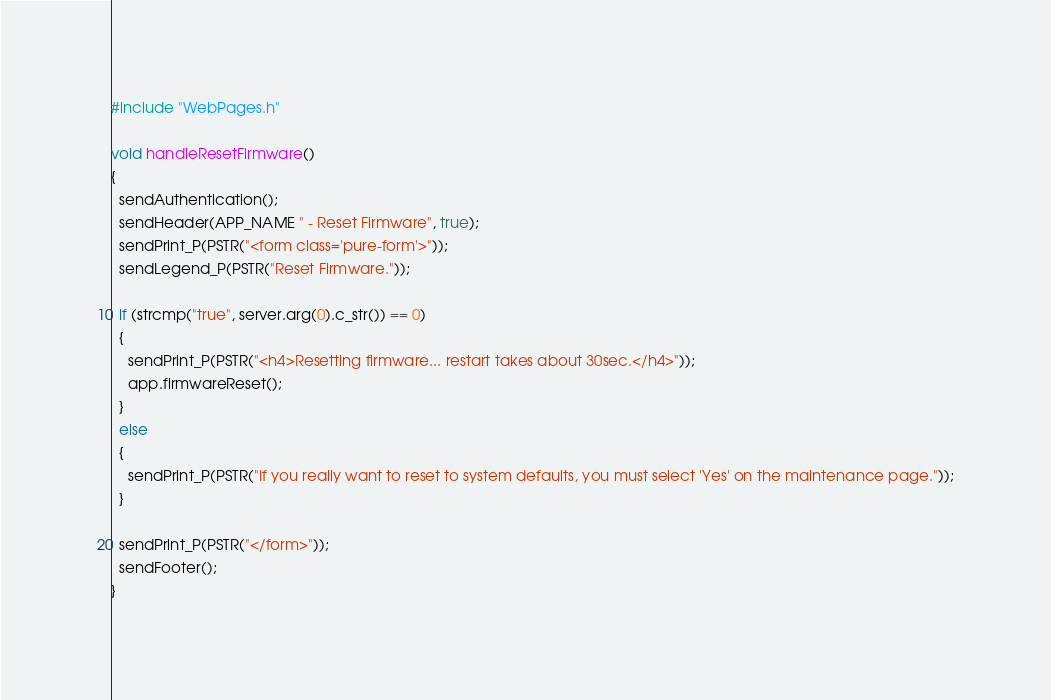<code> <loc_0><loc_0><loc_500><loc_500><_C++_>#include "WebPages.h"

void handleResetFirmware()
{
  sendAuthentication();
  sendHeader(APP_NAME " - Reset Firmware", true);
  sendPrint_P(PSTR("<form class='pure-form'>"));
  sendLegend_P(PSTR("Reset Firmware."));

  if (strcmp("true", server.arg(0).c_str()) == 0)
  {
    sendPrint_P(PSTR("<h4>Resetting firmware... restart takes about 30sec.</h4>"));
    app.firmwareReset();
  }
  else
  {
    sendPrint_P(PSTR("If you really want to reset to system defaults, you must select 'Yes' on the maintenance page."));
  }

  sendPrint_P(PSTR("</form>"));
  sendFooter();
}
</code> 